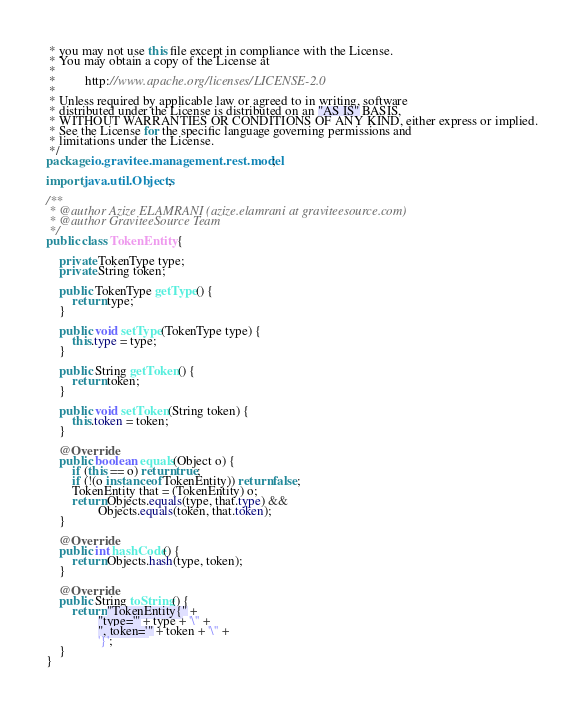Convert code to text. <code><loc_0><loc_0><loc_500><loc_500><_Java_> * you may not use this file except in compliance with the License.
 * You may obtain a copy of the License at
 *
 *         http://www.apache.org/licenses/LICENSE-2.0
 *
 * Unless required by applicable law or agreed to in writing, software
 * distributed under the License is distributed on an "AS IS" BASIS,
 * WITHOUT WARRANTIES OR CONDITIONS OF ANY KIND, either express or implied.
 * See the License for the specific language governing permissions and
 * limitations under the License.
 */
package io.gravitee.management.rest.model;

import java.util.Objects;

/**
 * @author Azize ELAMRANI (azize.elamrani at graviteesource.com)
 * @author GraviteeSource Team
 */
public class TokenEntity {

    private TokenType type;
    private String token;

    public TokenType getType() {
        return type;
    }

    public void setType(TokenType type) {
        this.type = type;
    }

    public String getToken() {
        return token;
    }

    public void setToken(String token) {
        this.token = token;
    }

    @Override
    public boolean equals(Object o) {
        if (this == o) return true;
        if (!(o instanceof TokenEntity)) return false;
        TokenEntity that = (TokenEntity) o;
        return Objects.equals(type, that.type) &&
                Objects.equals(token, that.token);
    }

    @Override
    public int hashCode() {
        return Objects.hash(type, token);
    }

    @Override
    public String toString() {
        return "TokenEntity{" +
                "type='" + type + '\'' +
                ", token='" + token + '\'' +
                '}';
    }
}
</code> 